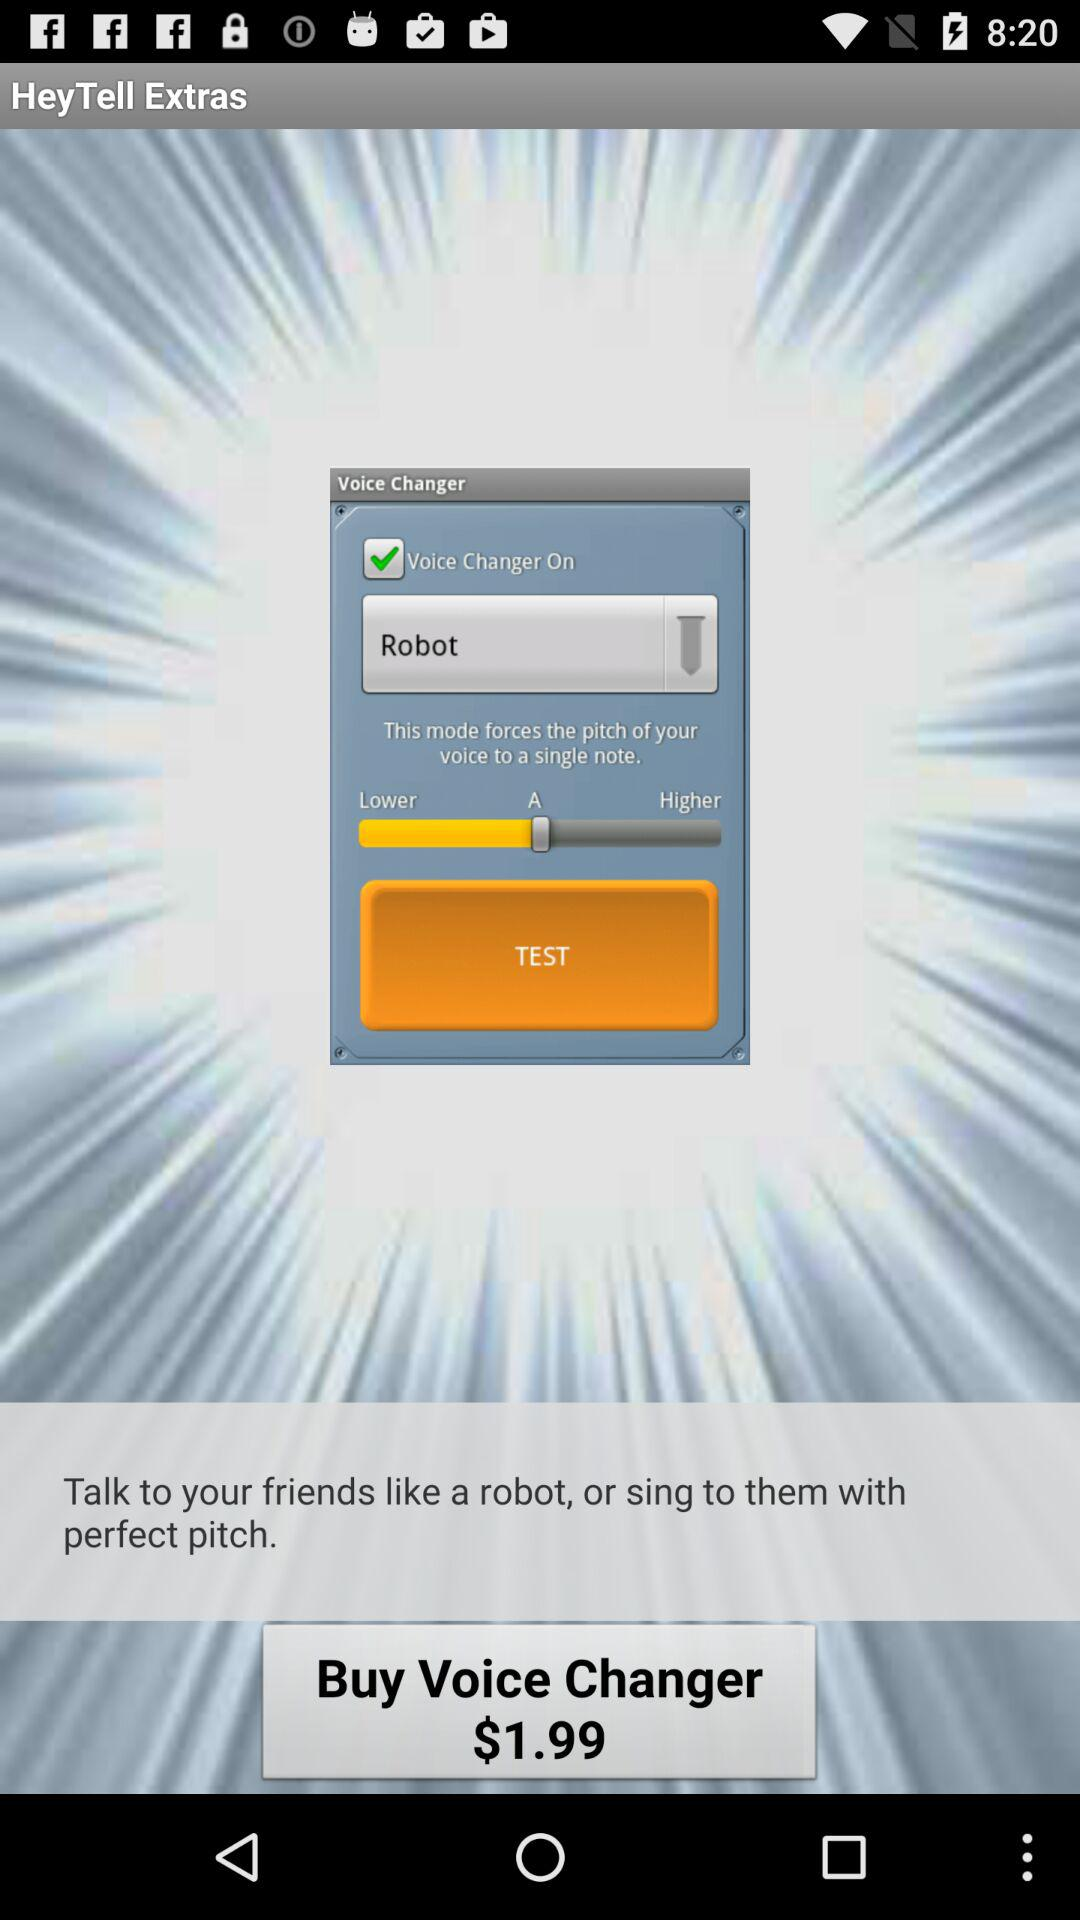What's the type of sound mode where user voice changed?
When the provided information is insufficient, respond with <no answer>. <no answer> 